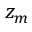<formula> <loc_0><loc_0><loc_500><loc_500>z _ { m }</formula> 